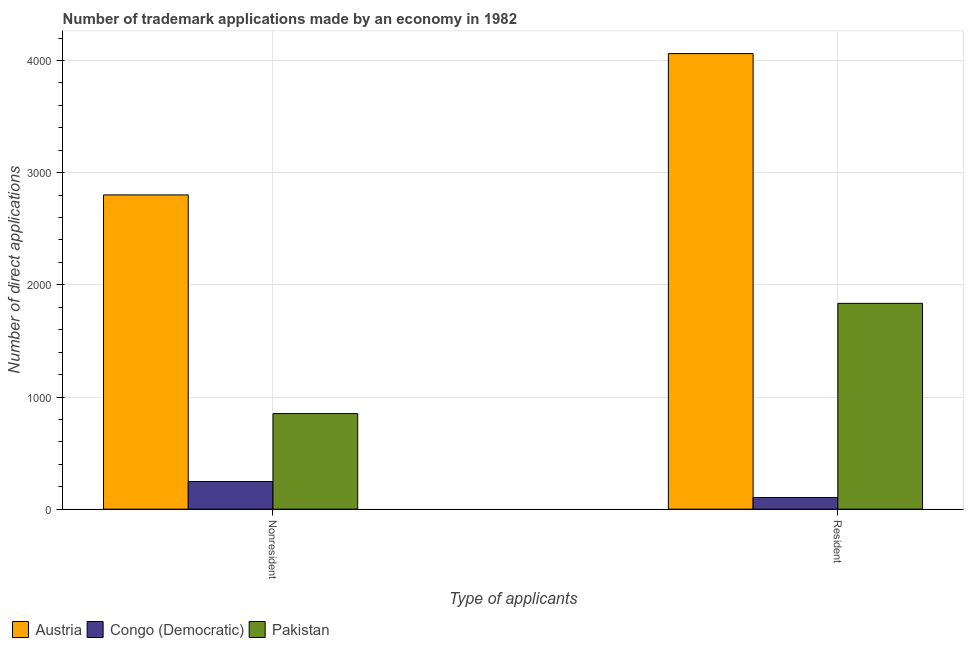Are the number of bars per tick equal to the number of legend labels?
Your answer should be very brief. Yes. What is the label of the 1st group of bars from the left?
Keep it short and to the point. Nonresident. What is the number of trademark applications made by non residents in Congo (Democratic)?
Ensure brevity in your answer.  246. Across all countries, what is the maximum number of trademark applications made by residents?
Your answer should be very brief. 4062. Across all countries, what is the minimum number of trademark applications made by non residents?
Your answer should be compact. 246. In which country was the number of trademark applications made by non residents maximum?
Keep it short and to the point. Austria. In which country was the number of trademark applications made by non residents minimum?
Make the answer very short. Congo (Democratic). What is the total number of trademark applications made by residents in the graph?
Provide a succinct answer. 6001. What is the difference between the number of trademark applications made by non residents in Congo (Democratic) and that in Austria?
Offer a very short reply. -2556. What is the difference between the number of trademark applications made by non residents in Congo (Democratic) and the number of trademark applications made by residents in Pakistan?
Your response must be concise. -1589. What is the average number of trademark applications made by residents per country?
Provide a succinct answer. 2000.33. What is the difference between the number of trademark applications made by residents and number of trademark applications made by non residents in Congo (Democratic)?
Offer a terse response. -142. In how many countries, is the number of trademark applications made by non residents greater than 2200 ?
Give a very brief answer. 1. What is the ratio of the number of trademark applications made by non residents in Pakistan to that in Austria?
Ensure brevity in your answer.  0.3. In how many countries, is the number of trademark applications made by residents greater than the average number of trademark applications made by residents taken over all countries?
Give a very brief answer. 1. What does the 2nd bar from the left in Resident represents?
Provide a succinct answer. Congo (Democratic). What does the 3rd bar from the right in Resident represents?
Provide a succinct answer. Austria. How many bars are there?
Offer a very short reply. 6. Are all the bars in the graph horizontal?
Offer a very short reply. No. How many legend labels are there?
Give a very brief answer. 3. How are the legend labels stacked?
Your response must be concise. Horizontal. What is the title of the graph?
Make the answer very short. Number of trademark applications made by an economy in 1982. Does "Ghana" appear as one of the legend labels in the graph?
Offer a very short reply. No. What is the label or title of the X-axis?
Offer a very short reply. Type of applicants. What is the label or title of the Y-axis?
Provide a succinct answer. Number of direct applications. What is the Number of direct applications of Austria in Nonresident?
Give a very brief answer. 2802. What is the Number of direct applications of Congo (Democratic) in Nonresident?
Give a very brief answer. 246. What is the Number of direct applications in Pakistan in Nonresident?
Provide a succinct answer. 852. What is the Number of direct applications in Austria in Resident?
Offer a very short reply. 4062. What is the Number of direct applications in Congo (Democratic) in Resident?
Ensure brevity in your answer.  104. What is the Number of direct applications of Pakistan in Resident?
Provide a short and direct response. 1835. Across all Type of applicants, what is the maximum Number of direct applications of Austria?
Your answer should be very brief. 4062. Across all Type of applicants, what is the maximum Number of direct applications of Congo (Democratic)?
Your response must be concise. 246. Across all Type of applicants, what is the maximum Number of direct applications of Pakistan?
Provide a succinct answer. 1835. Across all Type of applicants, what is the minimum Number of direct applications of Austria?
Provide a succinct answer. 2802. Across all Type of applicants, what is the minimum Number of direct applications in Congo (Democratic)?
Make the answer very short. 104. Across all Type of applicants, what is the minimum Number of direct applications in Pakistan?
Your answer should be very brief. 852. What is the total Number of direct applications in Austria in the graph?
Offer a terse response. 6864. What is the total Number of direct applications of Congo (Democratic) in the graph?
Offer a very short reply. 350. What is the total Number of direct applications of Pakistan in the graph?
Ensure brevity in your answer.  2687. What is the difference between the Number of direct applications in Austria in Nonresident and that in Resident?
Offer a very short reply. -1260. What is the difference between the Number of direct applications in Congo (Democratic) in Nonresident and that in Resident?
Offer a terse response. 142. What is the difference between the Number of direct applications of Pakistan in Nonresident and that in Resident?
Provide a short and direct response. -983. What is the difference between the Number of direct applications in Austria in Nonresident and the Number of direct applications in Congo (Democratic) in Resident?
Your answer should be very brief. 2698. What is the difference between the Number of direct applications of Austria in Nonresident and the Number of direct applications of Pakistan in Resident?
Give a very brief answer. 967. What is the difference between the Number of direct applications of Congo (Democratic) in Nonresident and the Number of direct applications of Pakistan in Resident?
Make the answer very short. -1589. What is the average Number of direct applications in Austria per Type of applicants?
Offer a terse response. 3432. What is the average Number of direct applications of Congo (Democratic) per Type of applicants?
Provide a short and direct response. 175. What is the average Number of direct applications of Pakistan per Type of applicants?
Ensure brevity in your answer.  1343.5. What is the difference between the Number of direct applications of Austria and Number of direct applications of Congo (Democratic) in Nonresident?
Ensure brevity in your answer.  2556. What is the difference between the Number of direct applications of Austria and Number of direct applications of Pakistan in Nonresident?
Provide a succinct answer. 1950. What is the difference between the Number of direct applications in Congo (Democratic) and Number of direct applications in Pakistan in Nonresident?
Offer a terse response. -606. What is the difference between the Number of direct applications of Austria and Number of direct applications of Congo (Democratic) in Resident?
Your answer should be very brief. 3958. What is the difference between the Number of direct applications of Austria and Number of direct applications of Pakistan in Resident?
Your answer should be very brief. 2227. What is the difference between the Number of direct applications in Congo (Democratic) and Number of direct applications in Pakistan in Resident?
Your response must be concise. -1731. What is the ratio of the Number of direct applications of Austria in Nonresident to that in Resident?
Your answer should be very brief. 0.69. What is the ratio of the Number of direct applications in Congo (Democratic) in Nonresident to that in Resident?
Offer a very short reply. 2.37. What is the ratio of the Number of direct applications of Pakistan in Nonresident to that in Resident?
Provide a short and direct response. 0.46. What is the difference between the highest and the second highest Number of direct applications of Austria?
Keep it short and to the point. 1260. What is the difference between the highest and the second highest Number of direct applications in Congo (Democratic)?
Offer a terse response. 142. What is the difference between the highest and the second highest Number of direct applications of Pakistan?
Your answer should be compact. 983. What is the difference between the highest and the lowest Number of direct applications of Austria?
Offer a very short reply. 1260. What is the difference between the highest and the lowest Number of direct applications in Congo (Democratic)?
Provide a succinct answer. 142. What is the difference between the highest and the lowest Number of direct applications of Pakistan?
Your answer should be very brief. 983. 